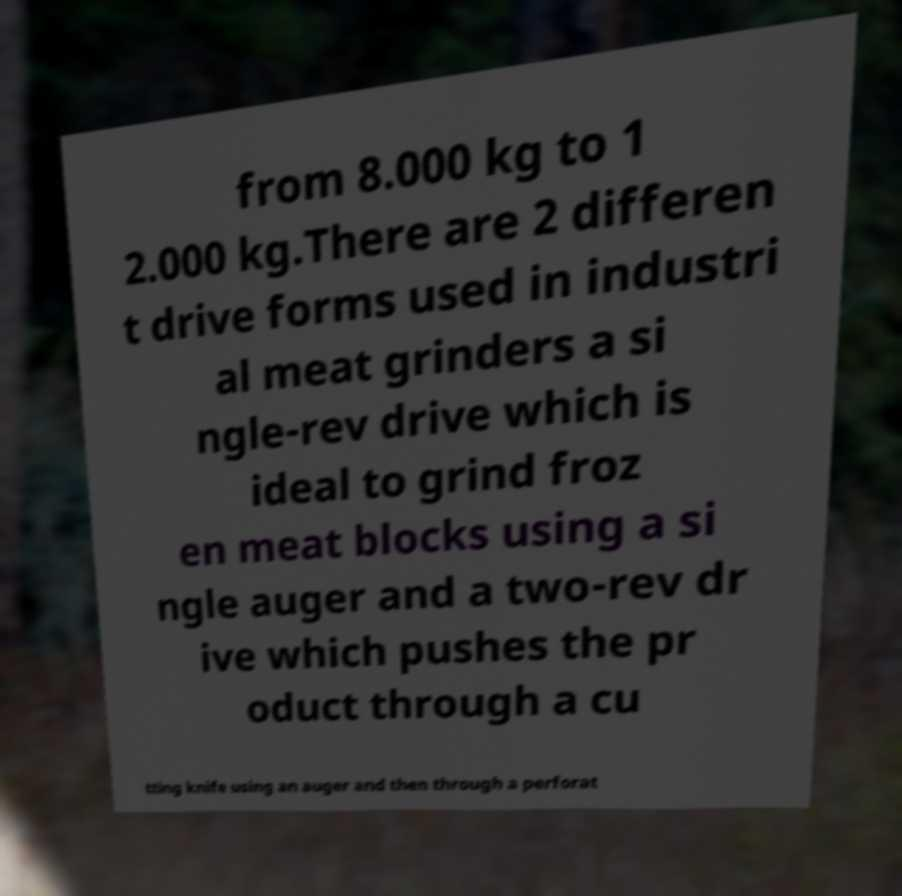I need the written content from this picture converted into text. Can you do that? from 8.000 kg to 1 2.000 kg.There are 2 differen t drive forms used in industri al meat grinders a si ngle-rev drive which is ideal to grind froz en meat blocks using a si ngle auger and a two-rev dr ive which pushes the pr oduct through a cu tting knife using an auger and then through a perforat 